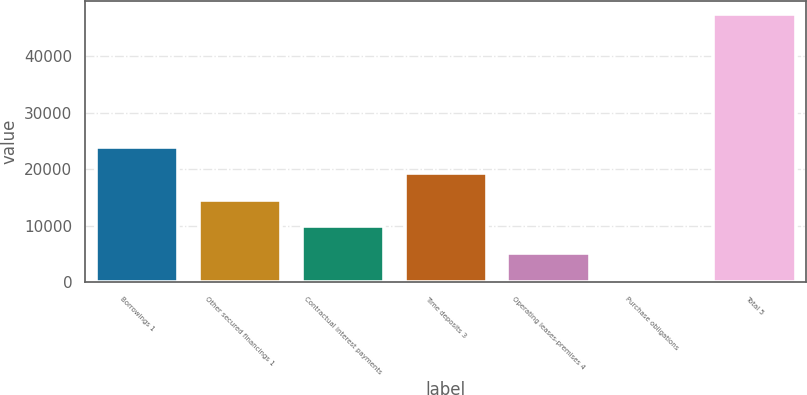<chart> <loc_0><loc_0><loc_500><loc_500><bar_chart><fcel>Borrowings 1<fcel>Other secured financings 1<fcel>Contractual interest payments<fcel>Time deposits 3<fcel>Operating leases-premises 4<fcel>Purchase obligations<fcel>Total 5<nl><fcel>23962.5<fcel>14616.7<fcel>9943.8<fcel>19289.6<fcel>5270.9<fcel>598<fcel>47327<nl></chart> 